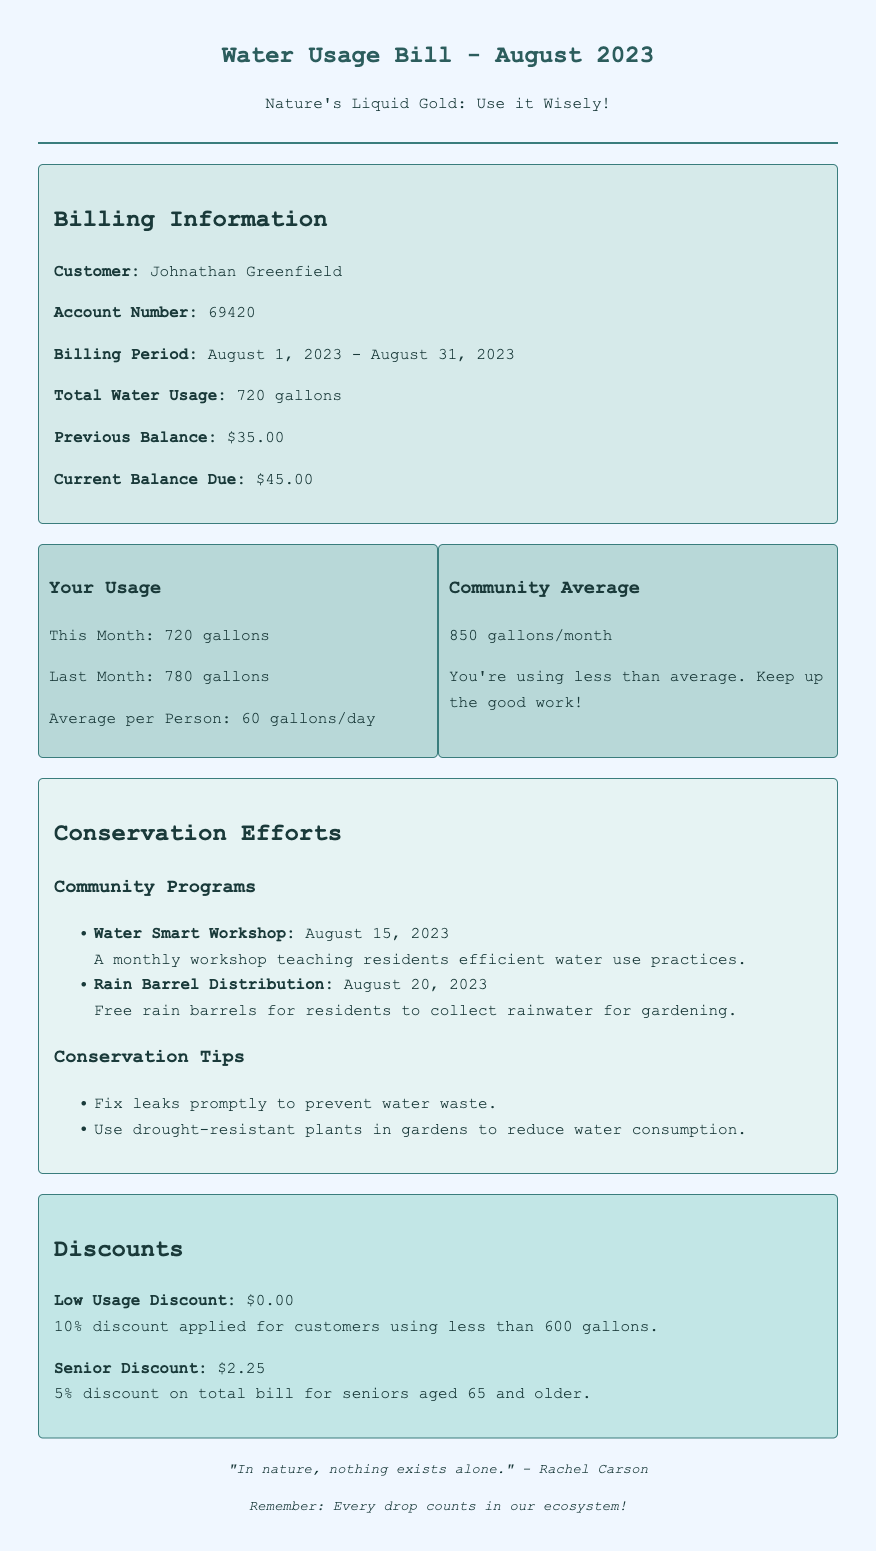What is the customer's name? The customer's name is provided in the billing information section of the document.
Answer: Johnathan Greenfield What is the account number? The account number is located in the billing information section.
Answer: 69420 What is the total water usage for August 2023? The total water usage can be found in the billing information section.
Answer: 720 gallons What was the community average usage for August? The community average usage is compared in the usage details section of the document.
Answer: 850 gallons/month What discount is available for seniors? The discount for seniors is specified in the discounts section of the document.
Answer: $2.25 What conservation program was held on August 15, 2023? The conservation programs and their dates are listed in the conservation efforts section.
Answer: Water Smart Workshop What conservation tip is given regarding garden plants? The conservation tips are stated in the conservation efforts section of the document.
Answer: Use drought-resistant plants How much is the low usage discount for the current bill? The low usage discount is mentioned in the discounts section of the document.
Answer: $0.00 What is the current balance due for the customer? The current balance in the billing information section indicates the total amount due.
Answer: $45.00 